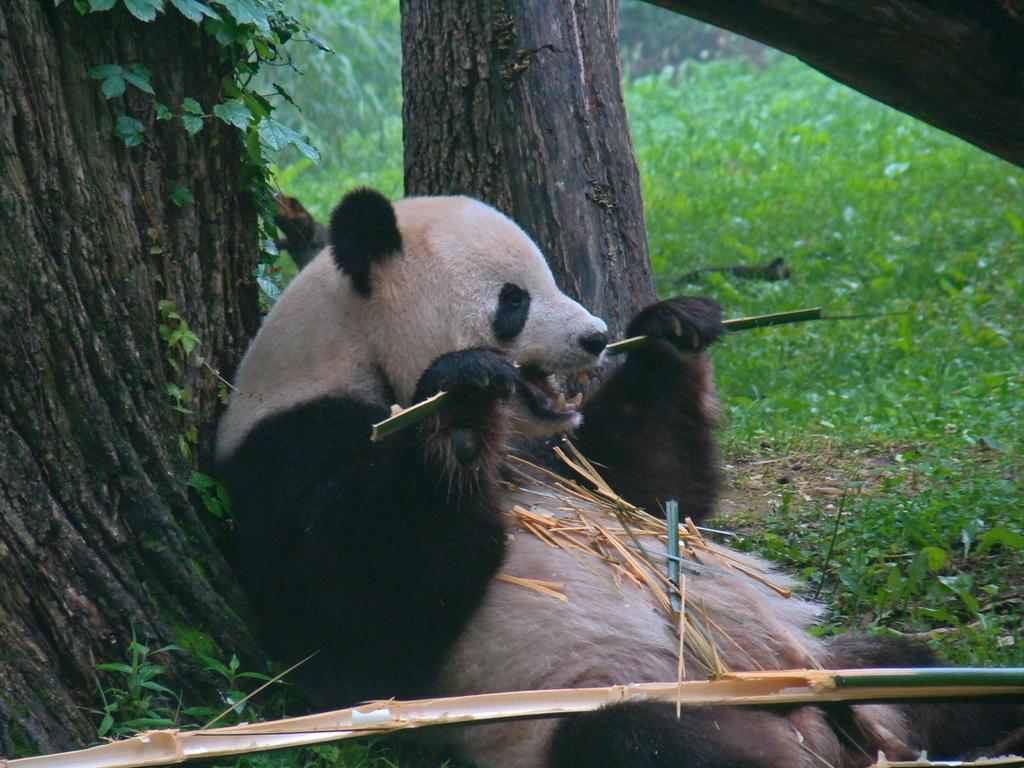What animal is present in the image? There is a bear in the image. Where is the bear located in relation to the tree trunk? The bear is sitting near a tree trunk. What object is the bear holding? The bear is holding a stick. What type of vegetation can be seen in the background of the image? There are plants and trees in the background of the image. What type of furniture can be seen in the image? There is no furniture present in the image; it features a bear sitting near a tree trunk. 